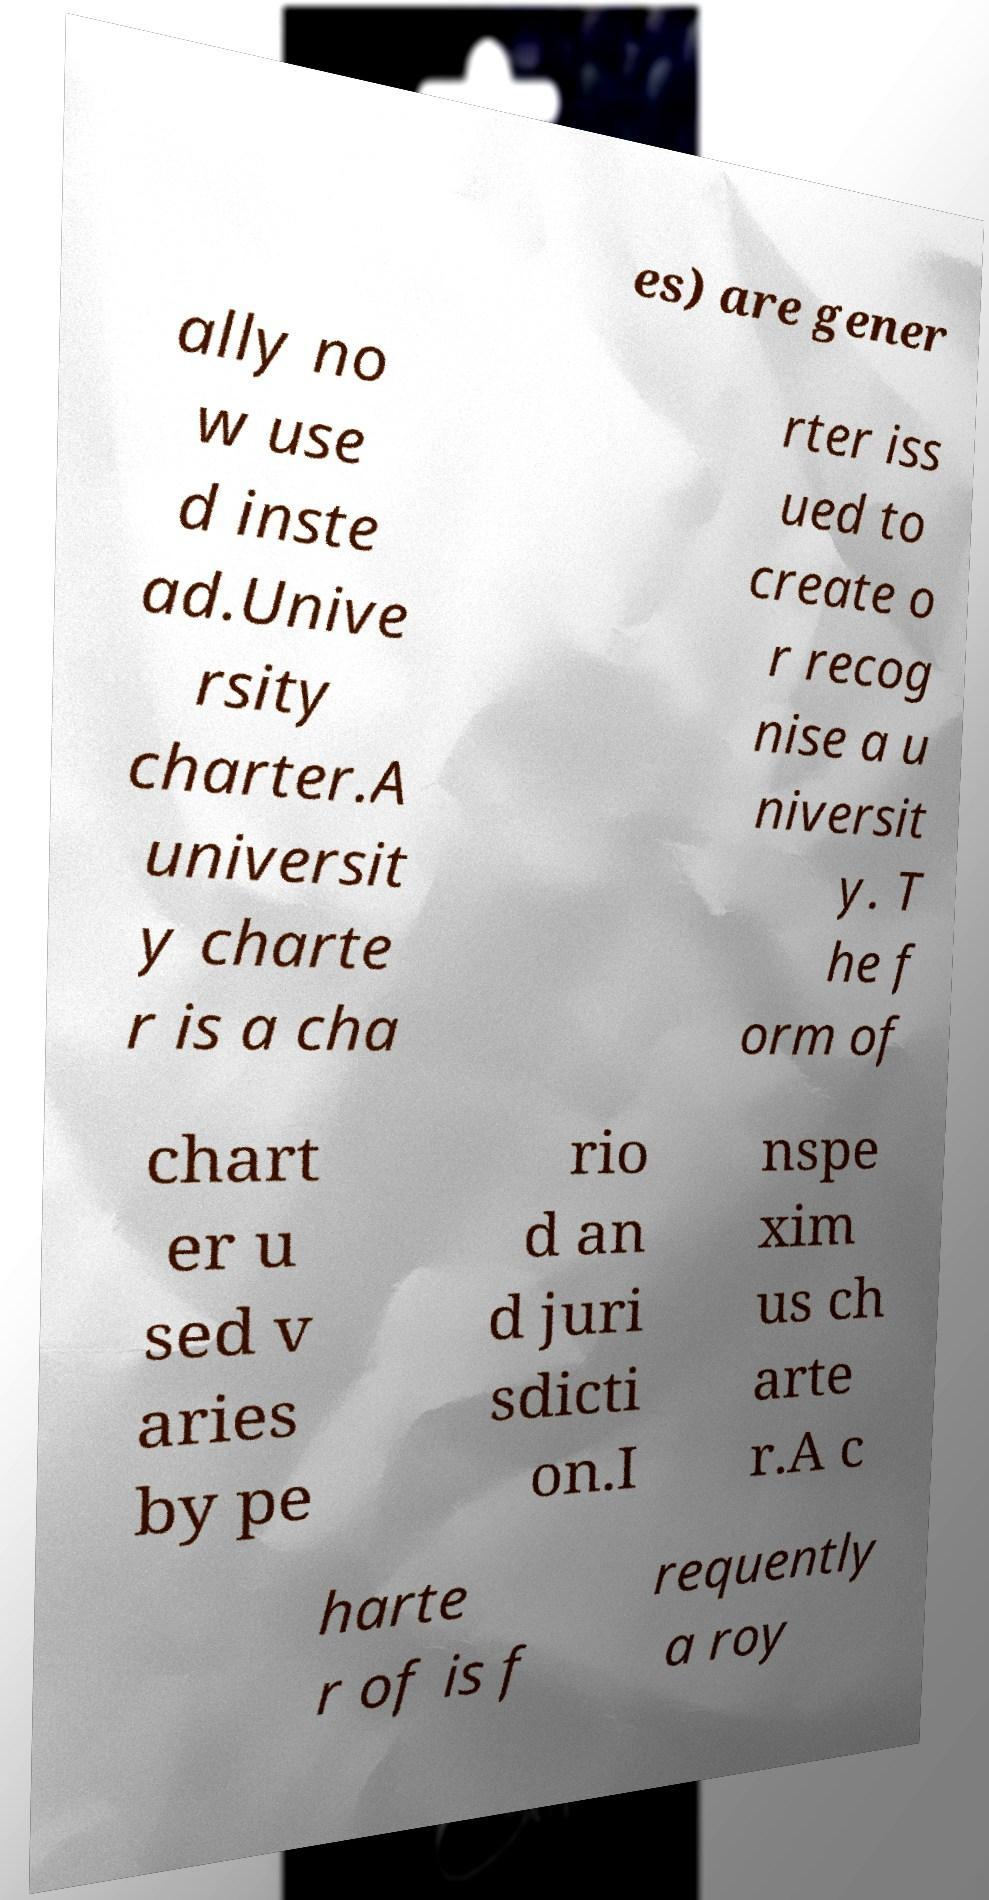For documentation purposes, I need the text within this image transcribed. Could you provide that? es) are gener ally no w use d inste ad.Unive rsity charter.A universit y charte r is a cha rter iss ued to create o r recog nise a u niversit y. T he f orm of chart er u sed v aries by pe rio d an d juri sdicti on.I nspe xim us ch arte r.A c harte r of is f requently a roy 